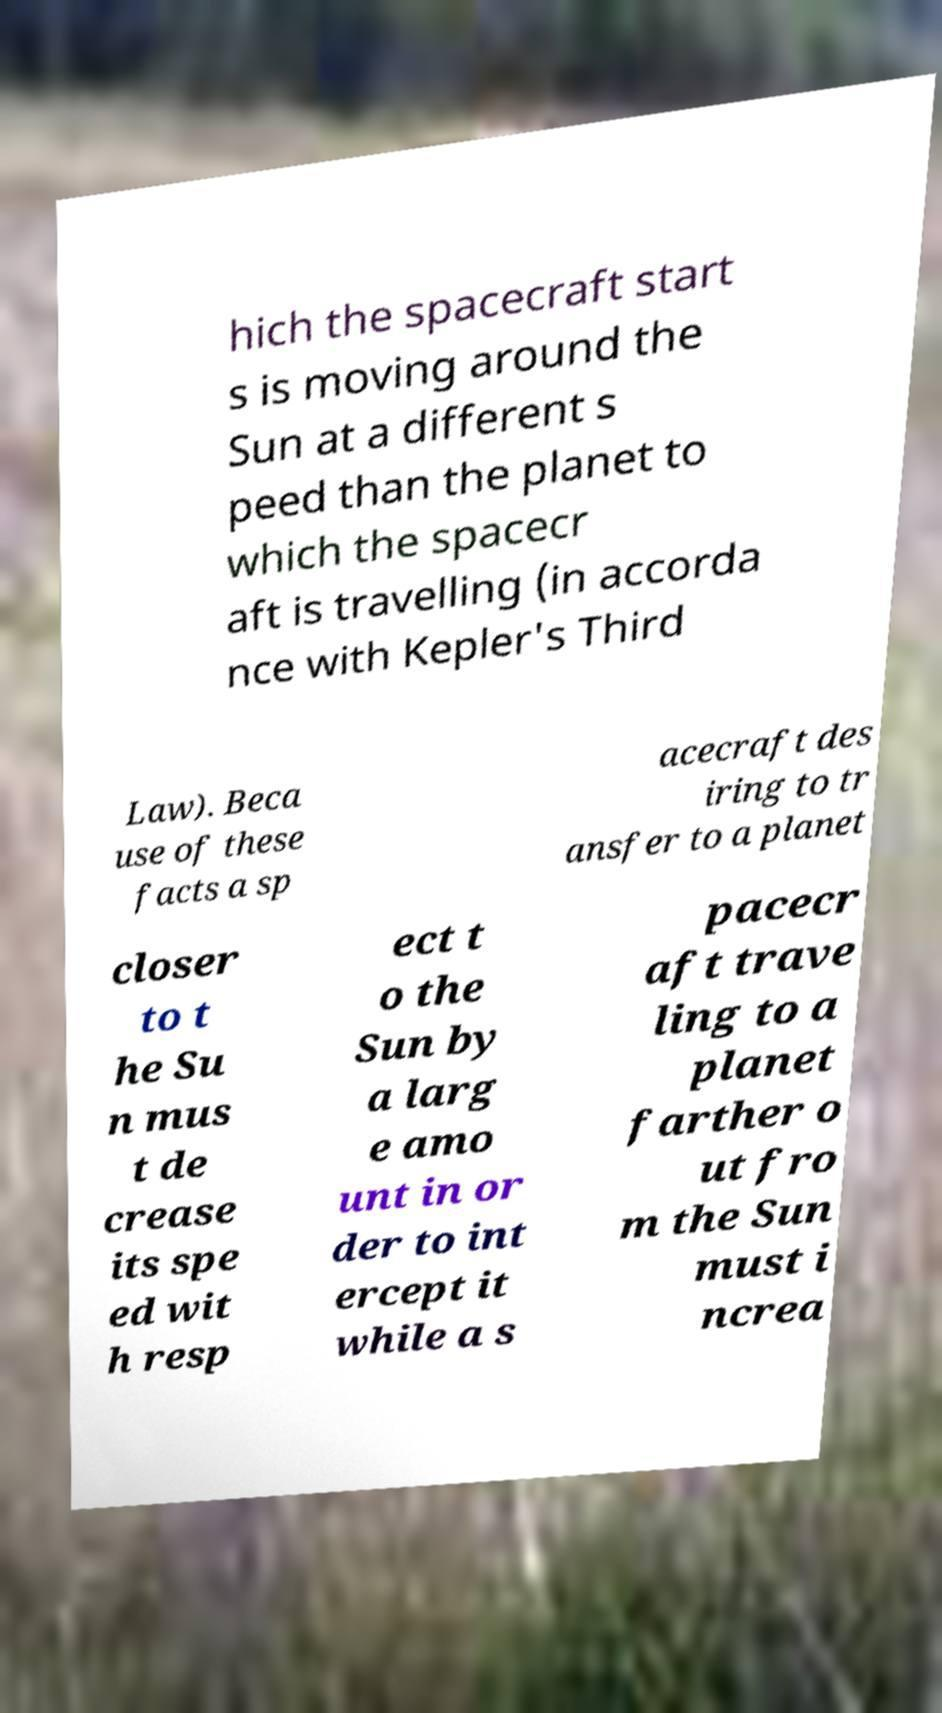Please identify and transcribe the text found in this image. hich the spacecraft start s is moving around the Sun at a different s peed than the planet to which the spacecr aft is travelling (in accorda nce with Kepler's Third Law). Beca use of these facts a sp acecraft des iring to tr ansfer to a planet closer to t he Su n mus t de crease its spe ed wit h resp ect t o the Sun by a larg e amo unt in or der to int ercept it while a s pacecr aft trave ling to a planet farther o ut fro m the Sun must i ncrea 